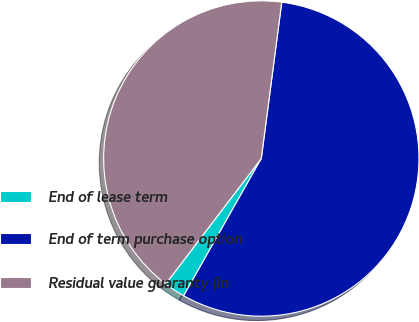Convert chart to OTSL. <chart><loc_0><loc_0><loc_500><loc_500><pie_chart><fcel>End of lease term<fcel>End of term purchase option<fcel>Residual value guaranty (in<nl><fcel>2.17%<fcel>56.12%<fcel>41.71%<nl></chart> 